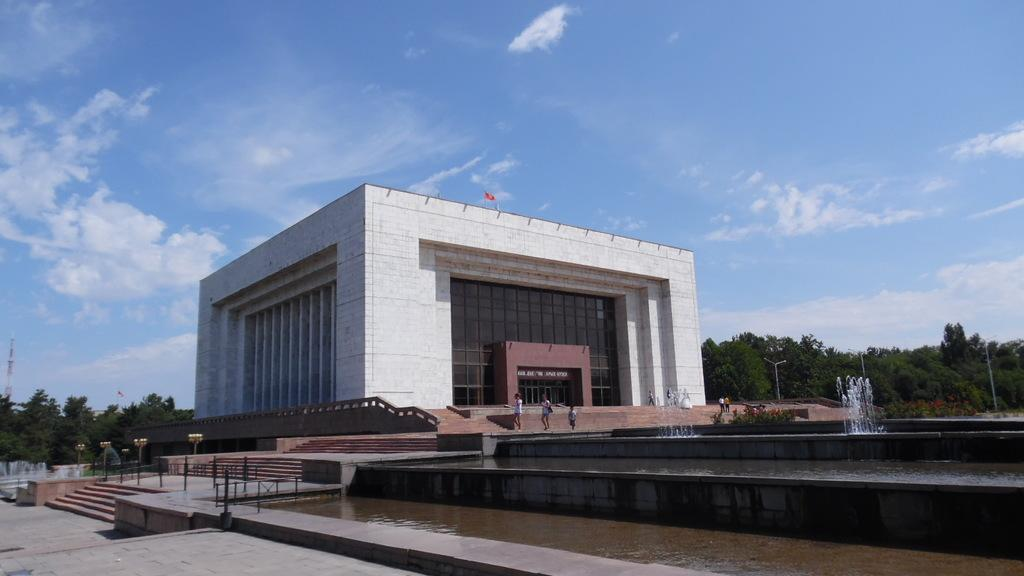What type of structure is present in the image? There is a building in the image. What is the color of the building? The building is white in color. What is located in front of the building? There is water in front of the building. What can be seen in the background of the image? There are trees in the background of the image. Reasoning: Let' Let's think step by step in order to produce the conversation. We start by identifying the main subject in the image, which is the building. Then, we expand the conversation to include other details about the building, such as its color. Next, we describe the surrounding environment, including the water in front of the building and the trees in the background. Each question is designed to elicit a specific detail about the image that is known from the provided facts. Absurd Question/Answer: What type of mountain, or nation can be seen in the image? There is no mountain, jump, or nation present in the image. The image features a white building with water in front and trees in the background. What type of mountain, or nation can be seen in the image? There is no mountain, jump, or nation present in the image. The image features a white building with water in front and trees in the background. 